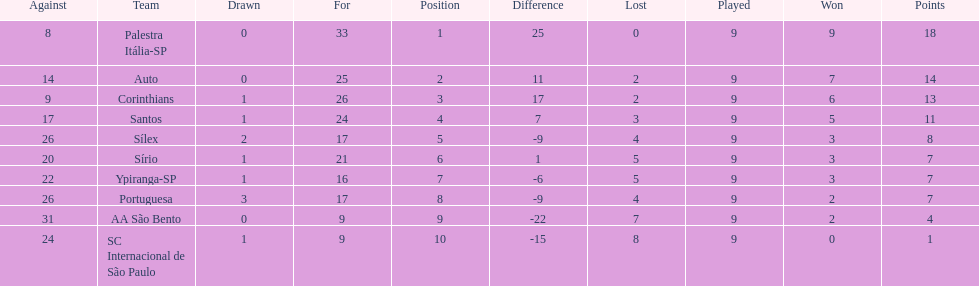Which is the only team to score 13 points in 9 games? Corinthians. 